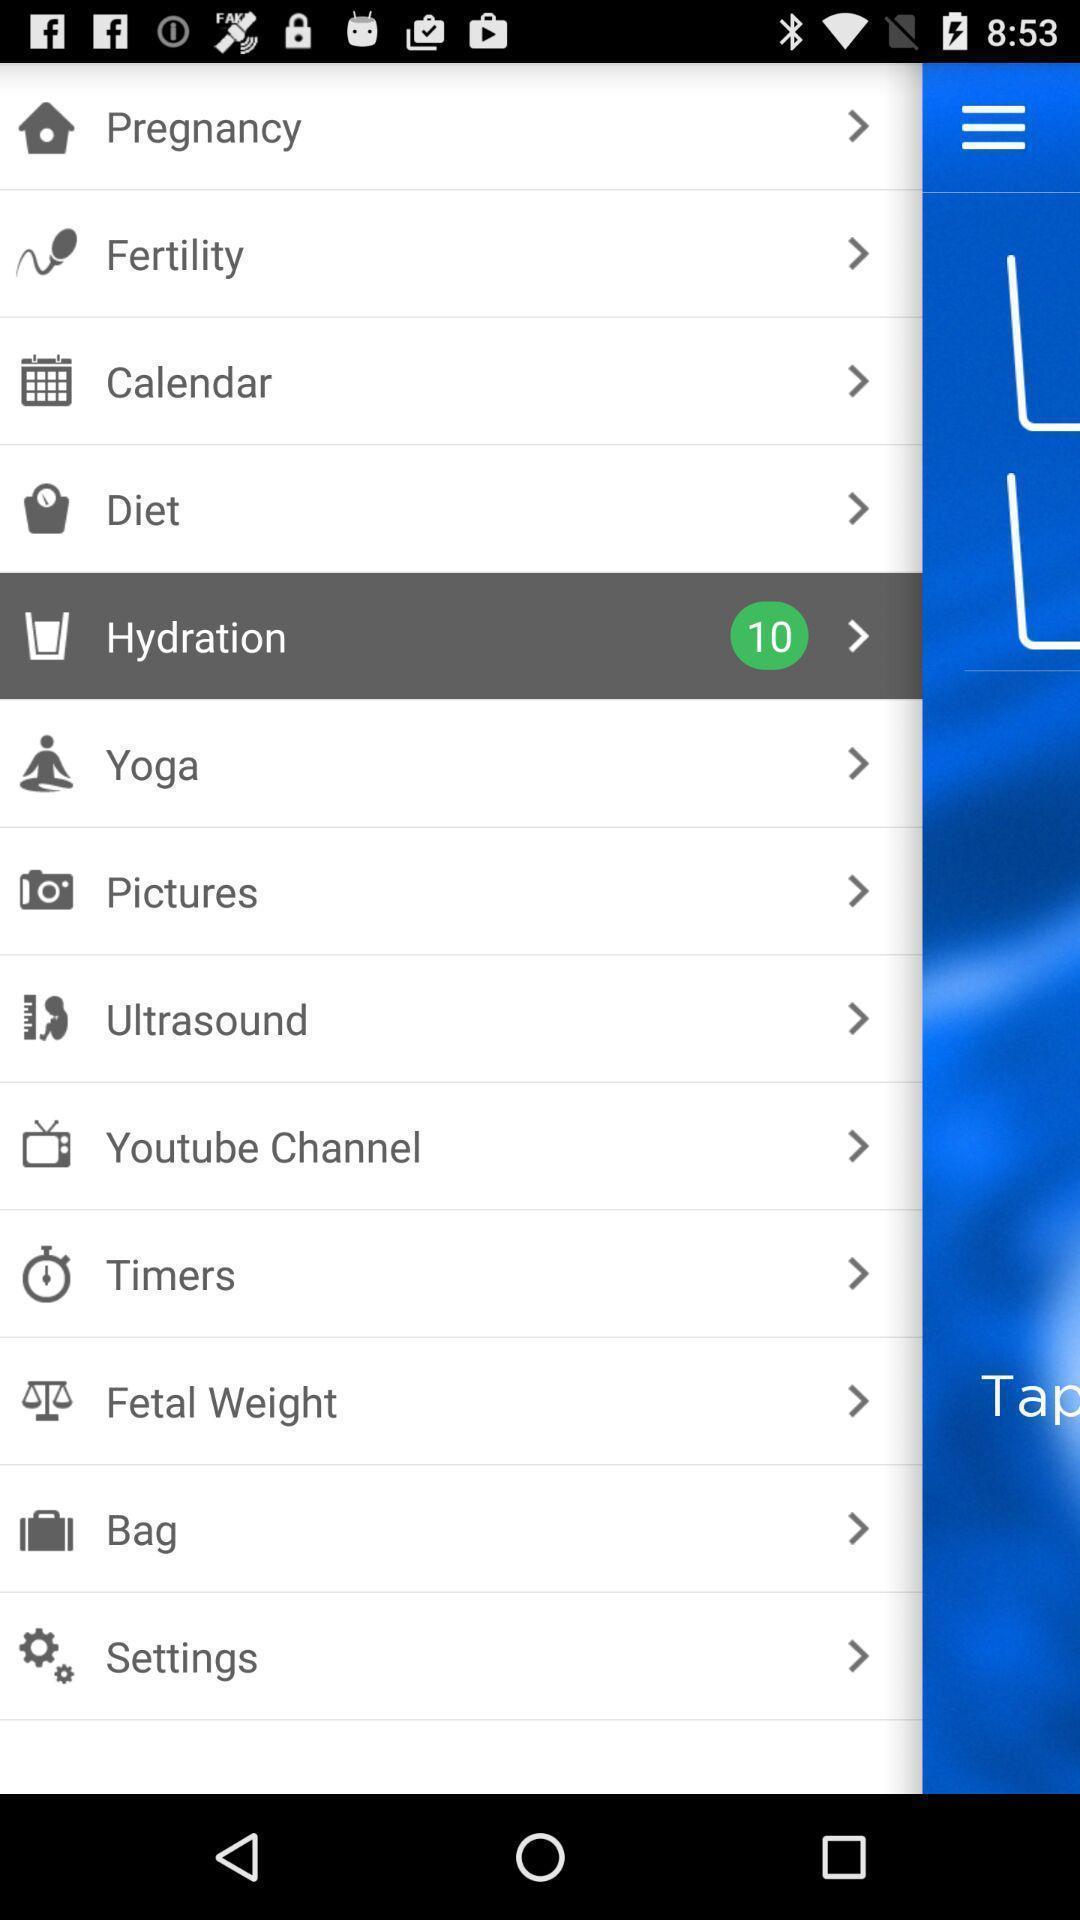What is the overall content of this screenshot? Page showing different options. 